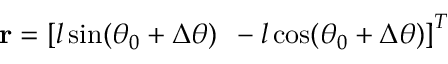<formula> <loc_0><loc_0><loc_500><loc_500>r = \left [ l \sin ( \theta _ { 0 } + \Delta \theta ) \, - l \cos ( \theta _ { 0 } + \Delta \theta ) \right ] ^ { T }</formula> 